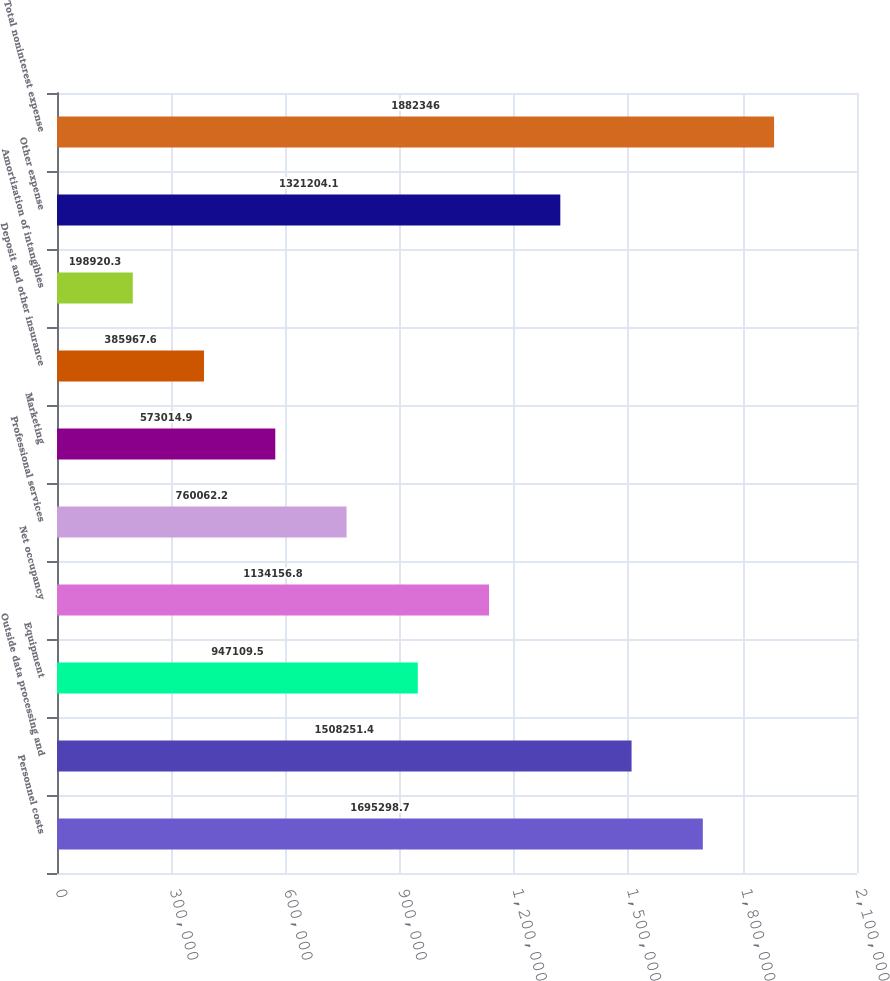Convert chart to OTSL. <chart><loc_0><loc_0><loc_500><loc_500><bar_chart><fcel>Personnel costs<fcel>Outside data processing and<fcel>Equipment<fcel>Net occupancy<fcel>Professional services<fcel>Marketing<fcel>Deposit and other insurance<fcel>Amortization of intangibles<fcel>Other expense<fcel>Total noninterest expense<nl><fcel>1.6953e+06<fcel>1.50825e+06<fcel>947110<fcel>1.13416e+06<fcel>760062<fcel>573015<fcel>385968<fcel>198920<fcel>1.3212e+06<fcel>1.88235e+06<nl></chart> 